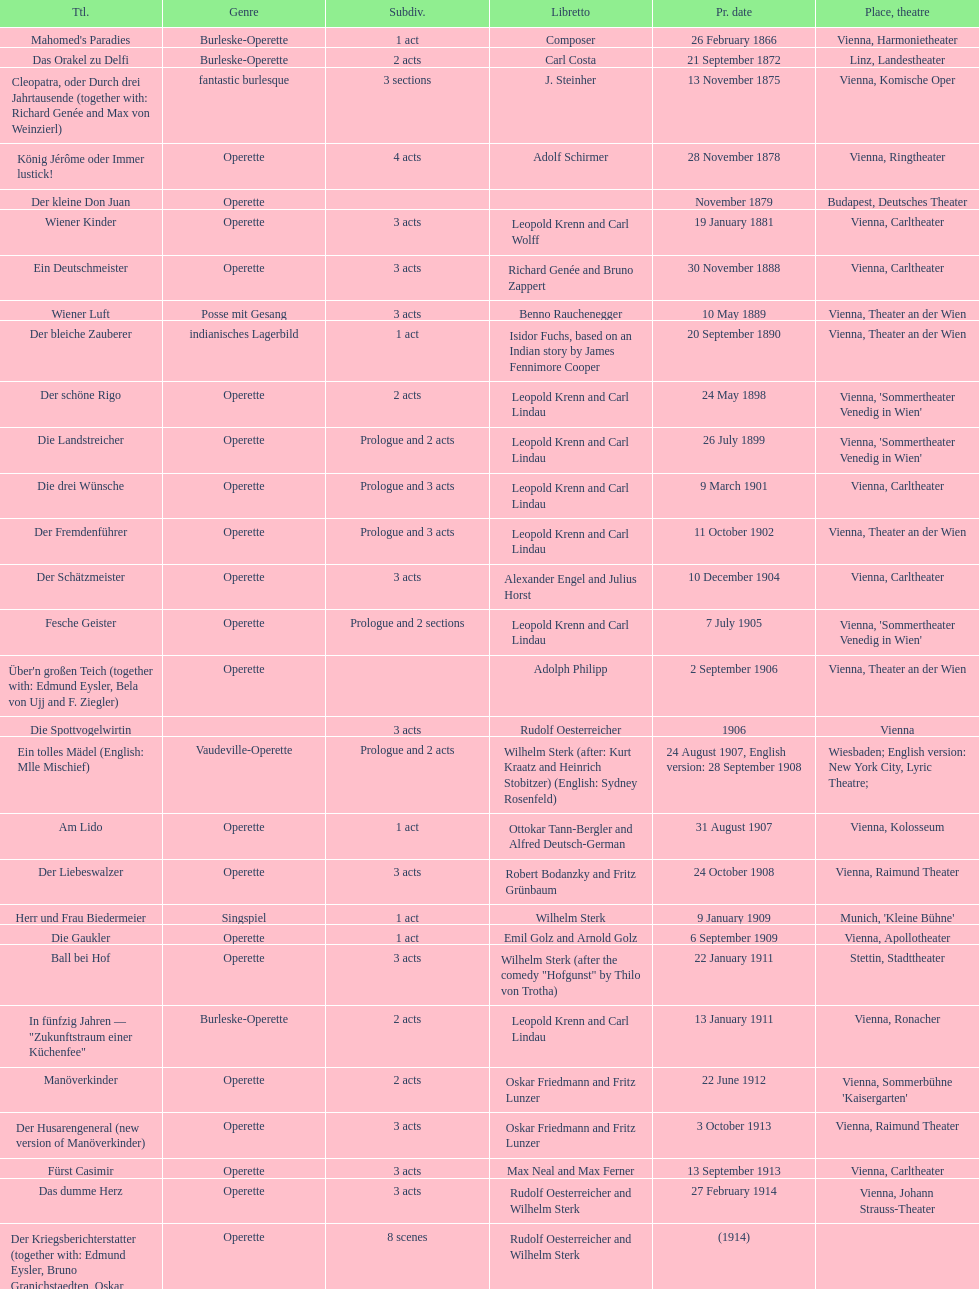In which city did the most operettas premiere? Vienna. 